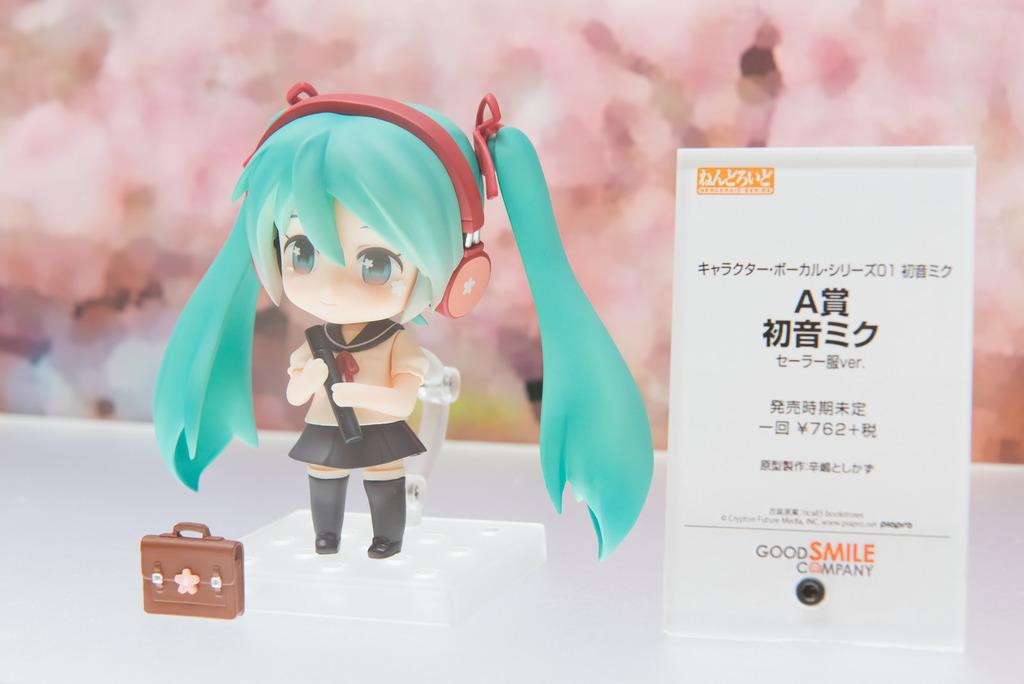Who is the main subject in the image? There is a girl in the image. What is the girl holding in the image? The girl is holding a suitcase. What else can be seen in the image besides the girl? There is a board in the image. What is written on the board? There is text on the board. How many shoes are visible in the image? There are no shoes visible in the image. What month is it in the image? The month is not mentioned or depicted in the image. 